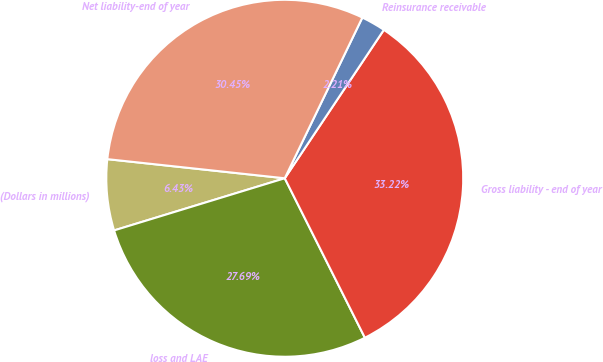Convert chart. <chart><loc_0><loc_0><loc_500><loc_500><pie_chart><fcel>(Dollars in millions)<fcel>loss and LAE<fcel>Gross liability - end of year<fcel>Reinsurance receivable<fcel>Net liability-end of year<nl><fcel>6.43%<fcel>27.69%<fcel>33.22%<fcel>2.21%<fcel>30.45%<nl></chart> 